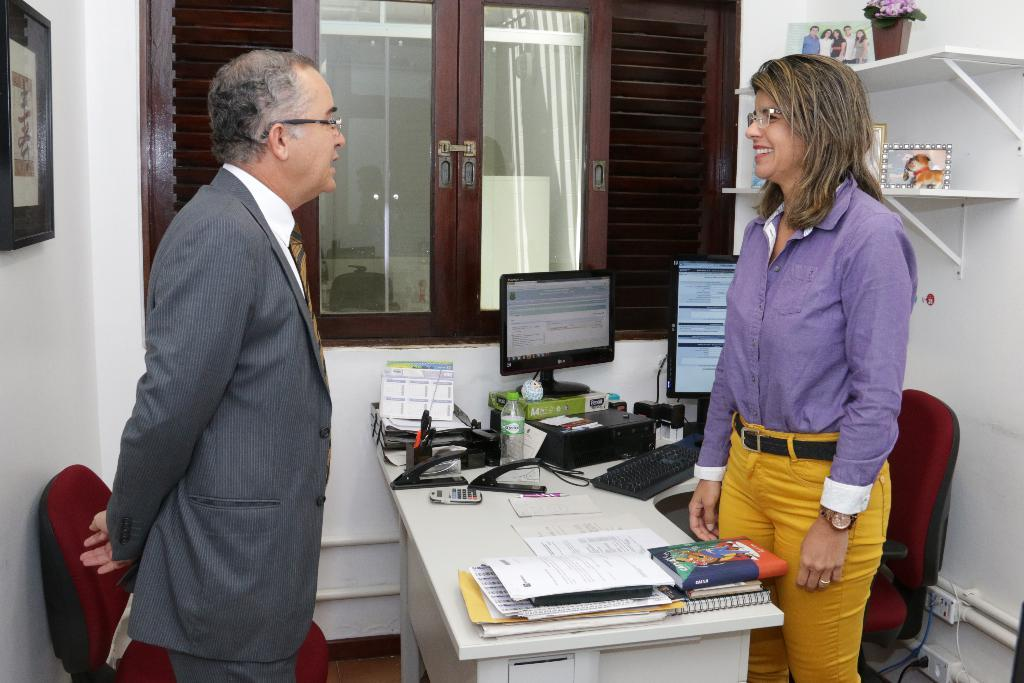How many people are in the image? There are two persons in the image: a man and a woman. What is the position of the man and woman in the image? The man and woman are standing opposite to each other. What is the main object in the image? There is a table in the image. What is placed on the table? There are two chairs, two systems, papers, and bottles on the table. What type of club is the man holding in the image? There is no club present in the image; the man and woman are not holding any clubs. How many hands are visible in the image? The image does not show any hands; it only shows the man and woman from the waist up. 